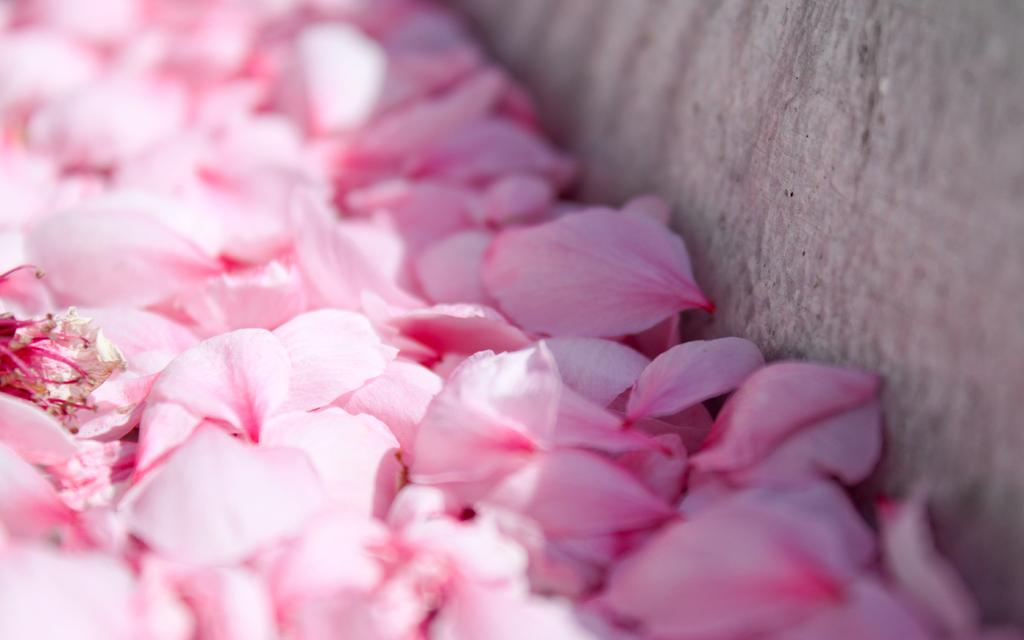What color are the petals in the image? The petals in the image are pink in color. What can be seen in the background of the image? There is a wall visible in the image. What type of insect can be seen crawling on the petals in the image? There is no insect present in the image; it only features pink petals and a wall. What invention is being used to water the petals in the image? There is no invention or device visible in the image for watering the petals. 